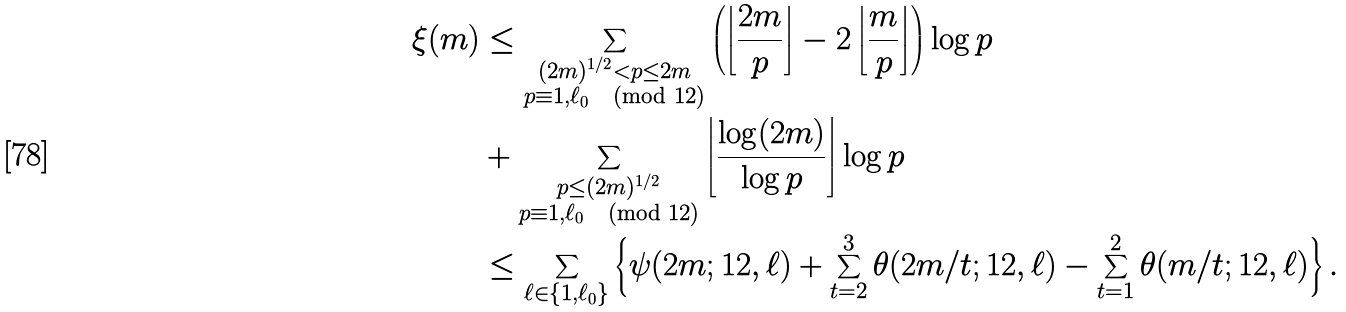Convert formula to latex. <formula><loc_0><loc_0><loc_500><loc_500>\xi ( m ) & \leq \sum _ { \substack { ( 2 m ) ^ { 1 / 2 } < p \leq 2 m \\ p \equiv 1 , \ell _ { 0 } \pmod { 1 2 } } } \left ( \left \lfloor \frac { 2 m } { p } \right \rfloor - 2 \left \lfloor \frac { m } { p } \right \rfloor \right ) \log p \\ & + \sum _ { \substack { p \leq ( 2 m ) ^ { 1 / 2 } \\ p \equiv 1 , \ell _ { 0 } \pmod { 1 2 } } } \left \lfloor \frac { \log ( 2 m ) } { \log p } \right \rfloor \log p \\ & \leq \sum _ { \ell \in \{ 1 , \ell _ { 0 } \} } \left \{ \psi ( 2 m ; 1 2 , \ell ) + \sum ^ { 3 } _ { t = 2 } \theta ( 2 m / t ; 1 2 , \ell ) - \sum ^ { 2 } _ { t = 1 } \theta ( m / t ; 1 2 , \ell ) \right \} .</formula> 